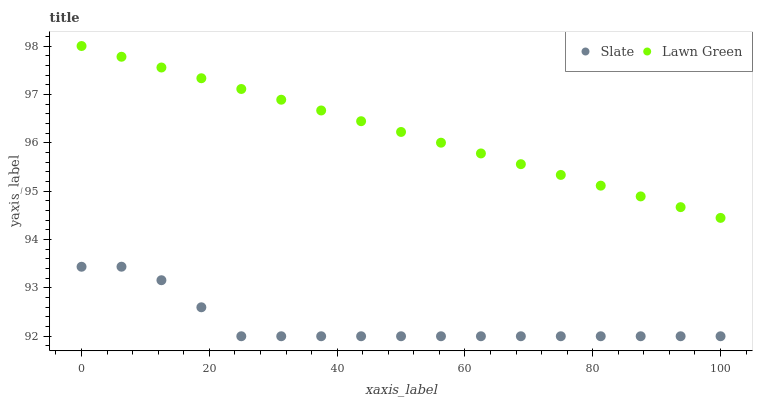Does Slate have the minimum area under the curve?
Answer yes or no. Yes. Does Lawn Green have the maximum area under the curve?
Answer yes or no. Yes. Does Slate have the maximum area under the curve?
Answer yes or no. No. Is Lawn Green the smoothest?
Answer yes or no. Yes. Is Slate the roughest?
Answer yes or no. Yes. Is Slate the smoothest?
Answer yes or no. No. Does Slate have the lowest value?
Answer yes or no. Yes. Does Lawn Green have the highest value?
Answer yes or no. Yes. Does Slate have the highest value?
Answer yes or no. No. Is Slate less than Lawn Green?
Answer yes or no. Yes. Is Lawn Green greater than Slate?
Answer yes or no. Yes. Does Slate intersect Lawn Green?
Answer yes or no. No. 